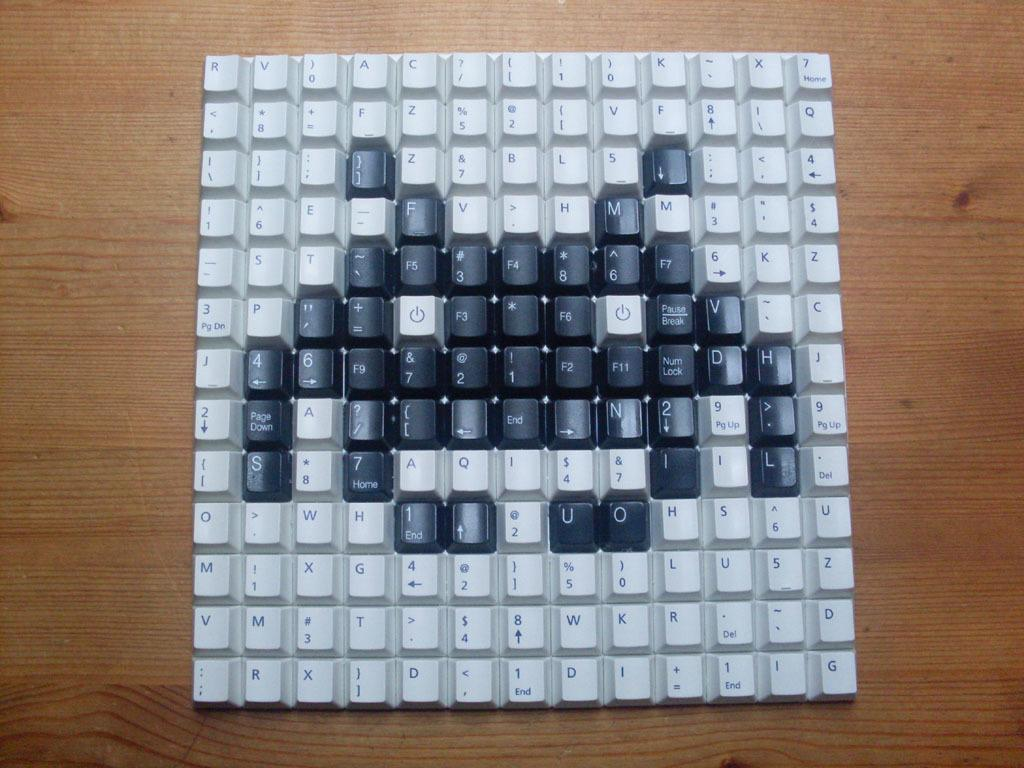<image>
Relay a brief, clear account of the picture shown. Keyboard buttons are laid out to make an image of a crab, with the U and O as its left claw. 